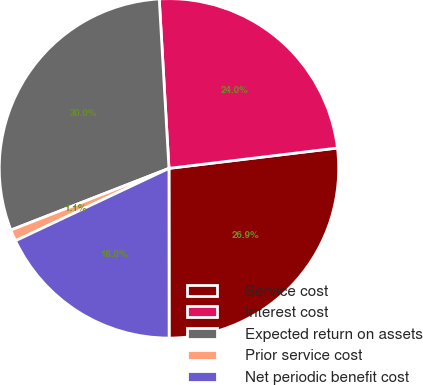<chart> <loc_0><loc_0><loc_500><loc_500><pie_chart><fcel>Service cost<fcel>Interest cost<fcel>Expected return on assets<fcel>Prior service cost<fcel>Net periodic benefit cost<nl><fcel>26.9%<fcel>24.0%<fcel>30.01%<fcel>1.09%<fcel>18.0%<nl></chart> 